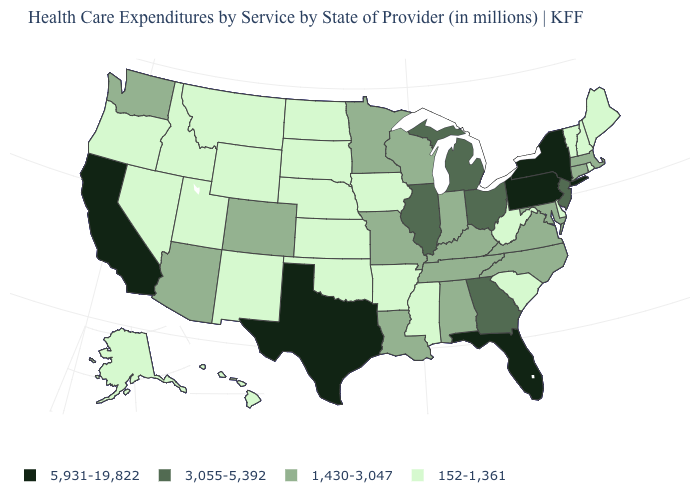Among the states that border North Dakota , which have the lowest value?
Give a very brief answer. Montana, South Dakota. What is the value of Pennsylvania?
Give a very brief answer. 5,931-19,822. What is the highest value in the USA?
Be succinct. 5,931-19,822. What is the value of Idaho?
Answer briefly. 152-1,361. Which states hav the highest value in the West?
Keep it brief. California. What is the value of Delaware?
Concise answer only. 152-1,361. Among the states that border North Carolina , does Virginia have the lowest value?
Write a very short answer. No. What is the value of Maine?
Answer briefly. 152-1,361. What is the lowest value in the USA?
Short answer required. 152-1,361. What is the lowest value in the West?
Keep it brief. 152-1,361. What is the highest value in states that border Nebraska?
Concise answer only. 1,430-3,047. Which states have the lowest value in the West?
Write a very short answer. Alaska, Hawaii, Idaho, Montana, Nevada, New Mexico, Oregon, Utah, Wyoming. What is the lowest value in the USA?
Answer briefly. 152-1,361. Does the map have missing data?
Quick response, please. No. What is the lowest value in states that border Indiana?
Concise answer only. 1,430-3,047. 